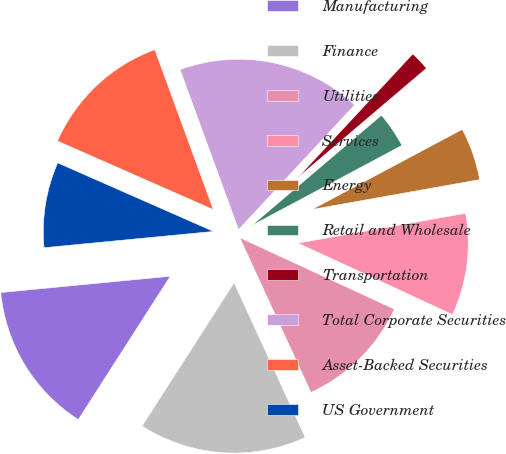Convert chart to OTSL. <chart><loc_0><loc_0><loc_500><loc_500><pie_chart><fcel>Manufacturing<fcel>Finance<fcel>Utilities<fcel>Services<fcel>Energy<fcel>Retail and Wholesale<fcel>Transportation<fcel>Total Corporate Securities<fcel>Asset-Backed Securities<fcel>US Government<nl><fcel>14.39%<fcel>15.95%<fcel>11.25%<fcel>9.69%<fcel>4.99%<fcel>3.42%<fcel>1.85%<fcel>17.52%<fcel>12.82%<fcel>8.12%<nl></chart> 